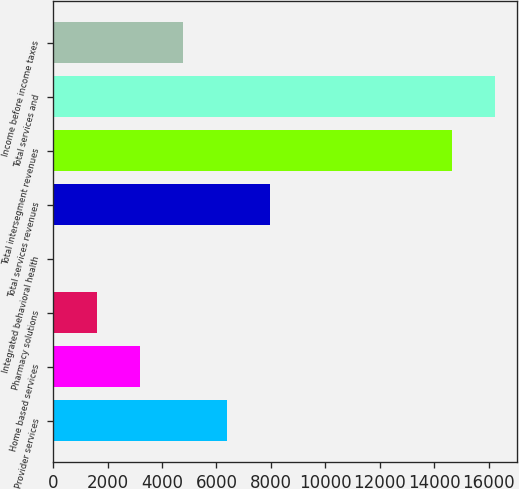<chart> <loc_0><loc_0><loc_500><loc_500><bar_chart><fcel>Provider services<fcel>Home based services<fcel>Pharmacy solutions<fcel>Integrated behavioral health<fcel>Total services revenues<fcel>Total intersegment revenues<fcel>Total services and<fcel>Income before income taxes<nl><fcel>6374.4<fcel>3188.2<fcel>1595.1<fcel>2<fcel>7967.5<fcel>14651<fcel>16244.1<fcel>4781.3<nl></chart> 